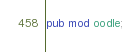Convert code to text. <code><loc_0><loc_0><loc_500><loc_500><_Rust_>pub mod oodle;</code> 